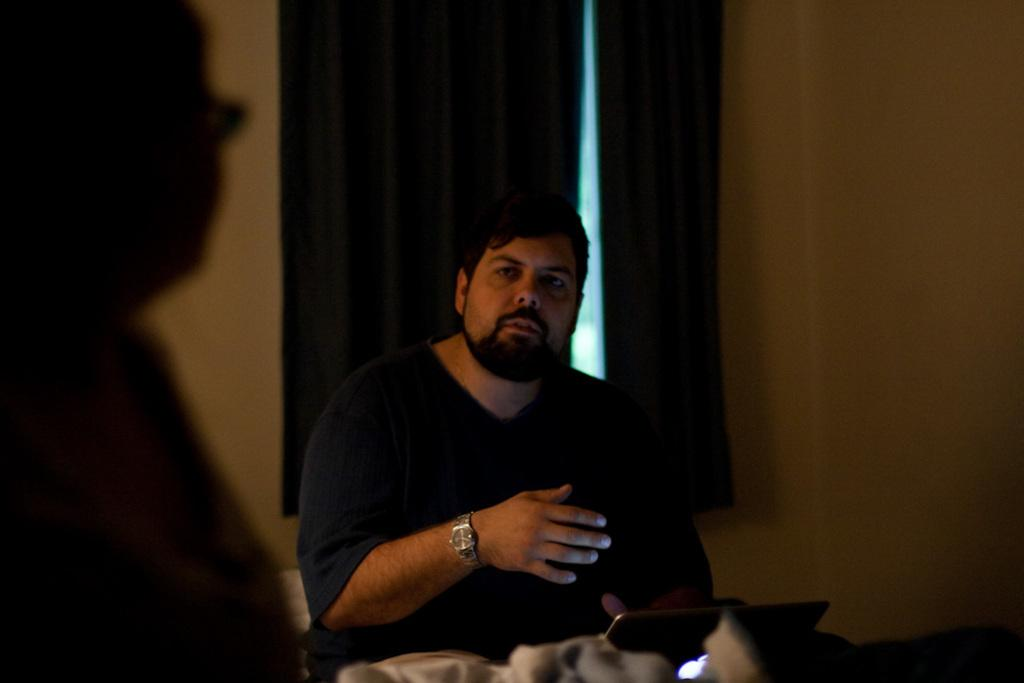What is the man in the image doing? The man is seated in the image. What object is visible on the table or desk in the image? There is a laptop in the image. What type of window treatment is present in the image? There are curtains near a window in the image. Can you describe the shadow in the image? There is a shadow of a human on the wall in the image. What type of tub is visible in the image? There is no tub present in the image. What occasion is being celebrated in the image? There is no indication of a birthday or any celebration in the image. 